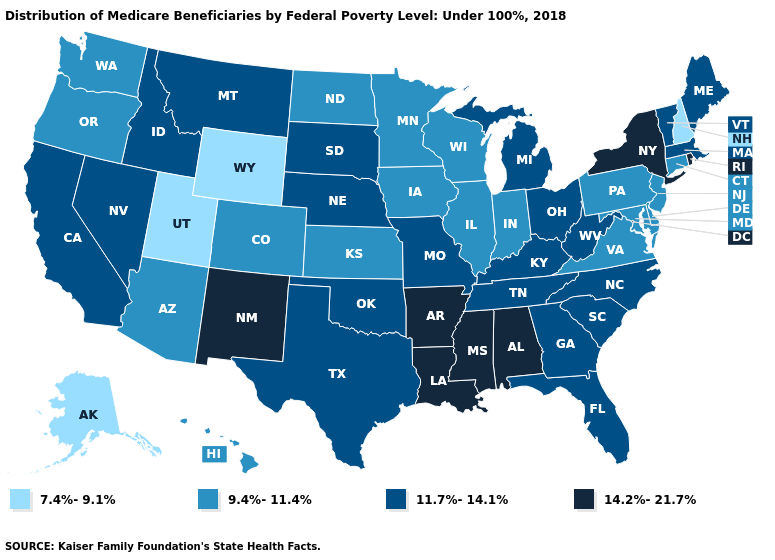Among the states that border New Mexico , does Utah have the lowest value?
Concise answer only. Yes. Does Rhode Island have the same value as New Mexico?
Concise answer only. Yes. Which states have the highest value in the USA?
Answer briefly. Alabama, Arkansas, Louisiana, Mississippi, New Mexico, New York, Rhode Island. Name the states that have a value in the range 14.2%-21.7%?
Keep it brief. Alabama, Arkansas, Louisiana, Mississippi, New Mexico, New York, Rhode Island. Name the states that have a value in the range 9.4%-11.4%?
Keep it brief. Arizona, Colorado, Connecticut, Delaware, Hawaii, Illinois, Indiana, Iowa, Kansas, Maryland, Minnesota, New Jersey, North Dakota, Oregon, Pennsylvania, Virginia, Washington, Wisconsin. Does Virginia have the highest value in the USA?
Keep it brief. No. Does the first symbol in the legend represent the smallest category?
Write a very short answer. Yes. What is the value of Washington?
Short answer required. 9.4%-11.4%. Name the states that have a value in the range 14.2%-21.7%?
Quick response, please. Alabama, Arkansas, Louisiana, Mississippi, New Mexico, New York, Rhode Island. Name the states that have a value in the range 11.7%-14.1%?
Be succinct. California, Florida, Georgia, Idaho, Kentucky, Maine, Massachusetts, Michigan, Missouri, Montana, Nebraska, Nevada, North Carolina, Ohio, Oklahoma, South Carolina, South Dakota, Tennessee, Texas, Vermont, West Virginia. What is the value of New Jersey?
Be succinct. 9.4%-11.4%. Name the states that have a value in the range 11.7%-14.1%?
Give a very brief answer. California, Florida, Georgia, Idaho, Kentucky, Maine, Massachusetts, Michigan, Missouri, Montana, Nebraska, Nevada, North Carolina, Ohio, Oklahoma, South Carolina, South Dakota, Tennessee, Texas, Vermont, West Virginia. Which states hav the highest value in the South?
Be succinct. Alabama, Arkansas, Louisiana, Mississippi. What is the value of Montana?
Short answer required. 11.7%-14.1%. 